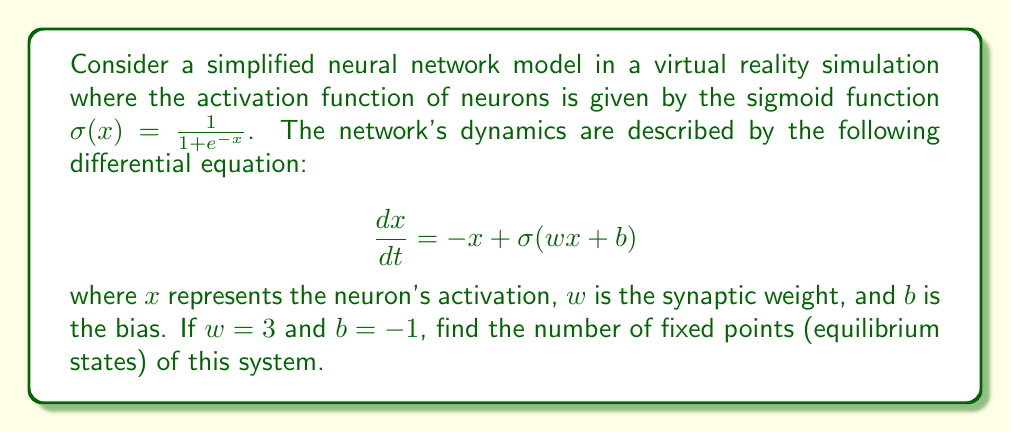Can you answer this question? To find the fixed points of this nonlinear system, we need to solve the equation:

$$\frac{dx}{dt} = 0$$

This gives us:

$$-x + \sigma(wx + b) = 0$$

Substituting the given values and the sigmoid function:

$$-x + \frac{1}{1 + e^{-(3x - 1)}} = 0$$

Rearranging the equation:

$$x = \frac{1}{1 + e^{-(3x - 1)}}$$

To solve this equation graphically, we need to find the intersections of $y = x$ and $y = \frac{1}{1 + e^{-(3x - 1)}}$.

[asy]
import graph;
size(200,200);
real f(real x) {return 1/(1+exp(-(3x-1)));}
draw(graph(f,0,1));
draw((0,0)--(1,1),gray);
xaxis("x",0,1,Arrow);
yaxis("y",0,1,Arrow);
label("y=x",(.8,.9),NE);
label("y=σ(3x-1)",(.2,.7),NW);
[/asy]

From the graph, we can see that there are three intersections between the two curves. These intersections represent the fixed points of the system.

To understand why there are three fixed points, we can analyze the behavior of the system:

1. For small $x$, the sigmoid function is close to 0, so $\frac{dx}{dt} < 0$, and $x$ decreases.
2. For large $x$, the sigmoid function approaches 1, so $\frac{dx}{dt} < 0$, and $x$ decreases.
3. In between, there's a region where the sigmoid function increases faster than $x$, creating two additional fixed points.

This behavior is characteristic of bistable systems in neuroscience, where neurons can have multiple stable states.
Answer: 3 fixed points 